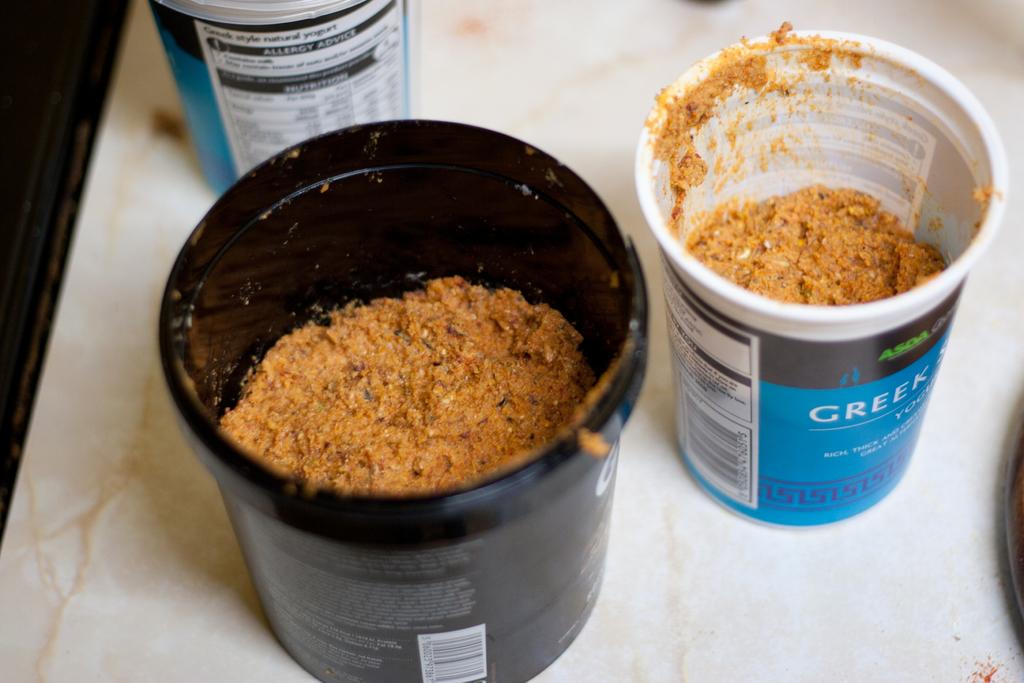What type of containers are visible in the image? There are plastic containers in the image. What is inside the containers? The containers have food in them. What color is the background of the image? The background of the image is white. Are there any cobwebs visible in the image? There are no cobwebs present in the image. What type of fuel is being used in the containers? The containers are not related to fuel; they contain food. 